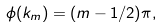Convert formula to latex. <formula><loc_0><loc_0><loc_500><loc_500>\phi ( k _ { m } ) = ( m - 1 / 2 ) \pi ,</formula> 